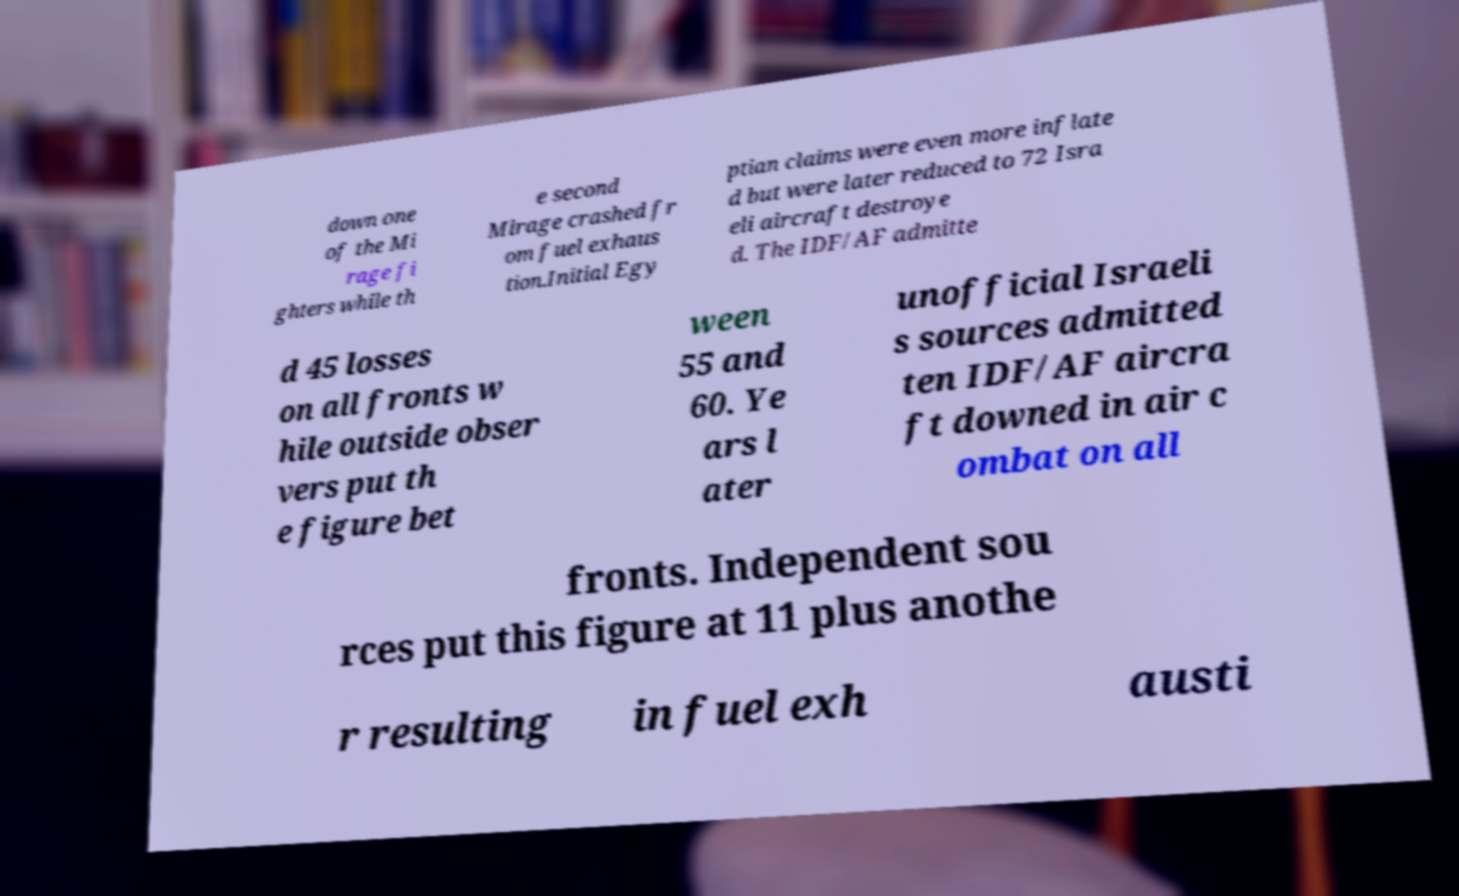What messages or text are displayed in this image? I need them in a readable, typed format. down one of the Mi rage fi ghters while th e second Mirage crashed fr om fuel exhaus tion.Initial Egy ptian claims were even more inflate d but were later reduced to 72 Isra eli aircraft destroye d. The IDF/AF admitte d 45 losses on all fronts w hile outside obser vers put th e figure bet ween 55 and 60. Ye ars l ater unofficial Israeli s sources admitted ten IDF/AF aircra ft downed in air c ombat on all fronts. Independent sou rces put this figure at 11 plus anothe r resulting in fuel exh austi 